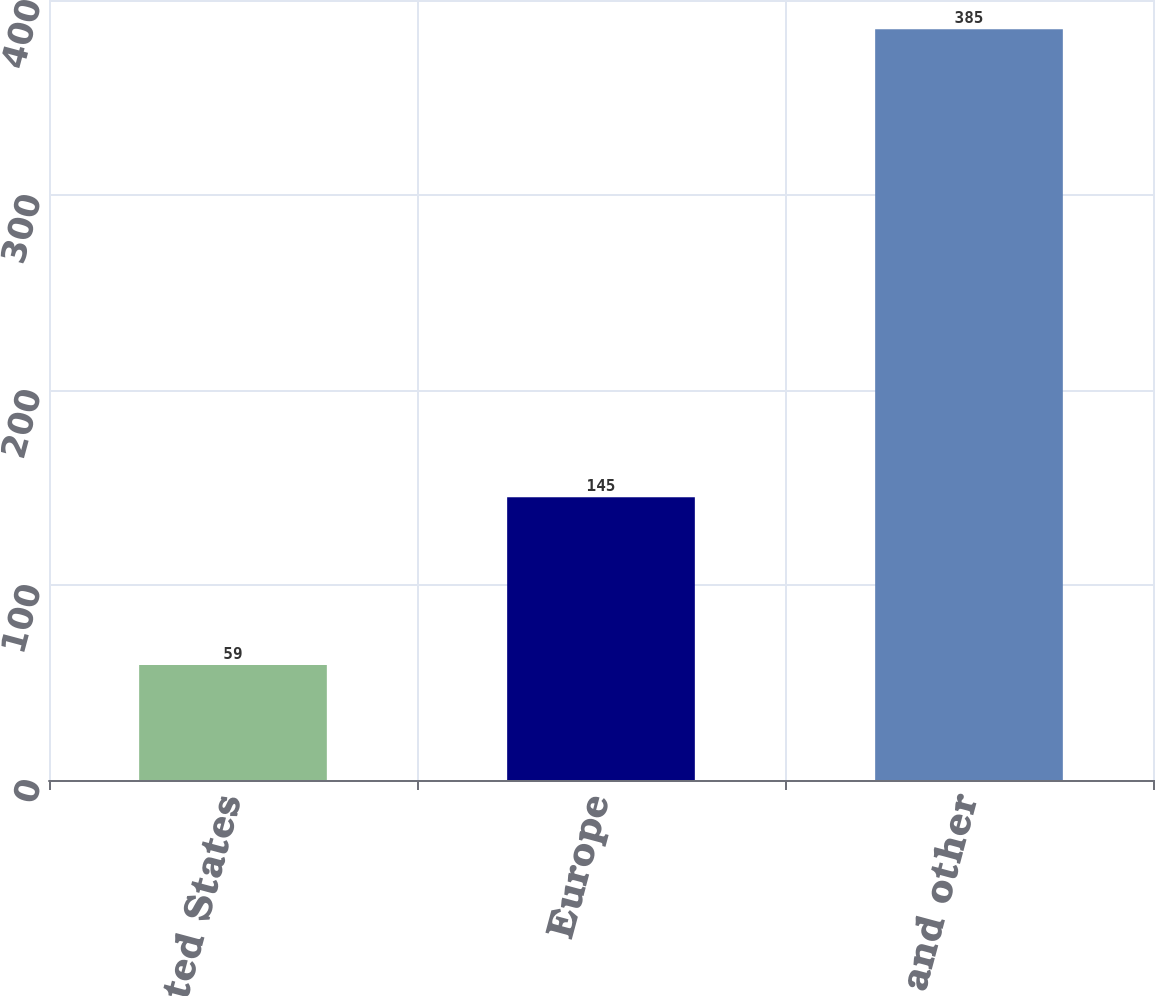Convert chart. <chart><loc_0><loc_0><loc_500><loc_500><bar_chart><fcel>United States<fcel>Europe<fcel>Asia and other<nl><fcel>59<fcel>145<fcel>385<nl></chart> 